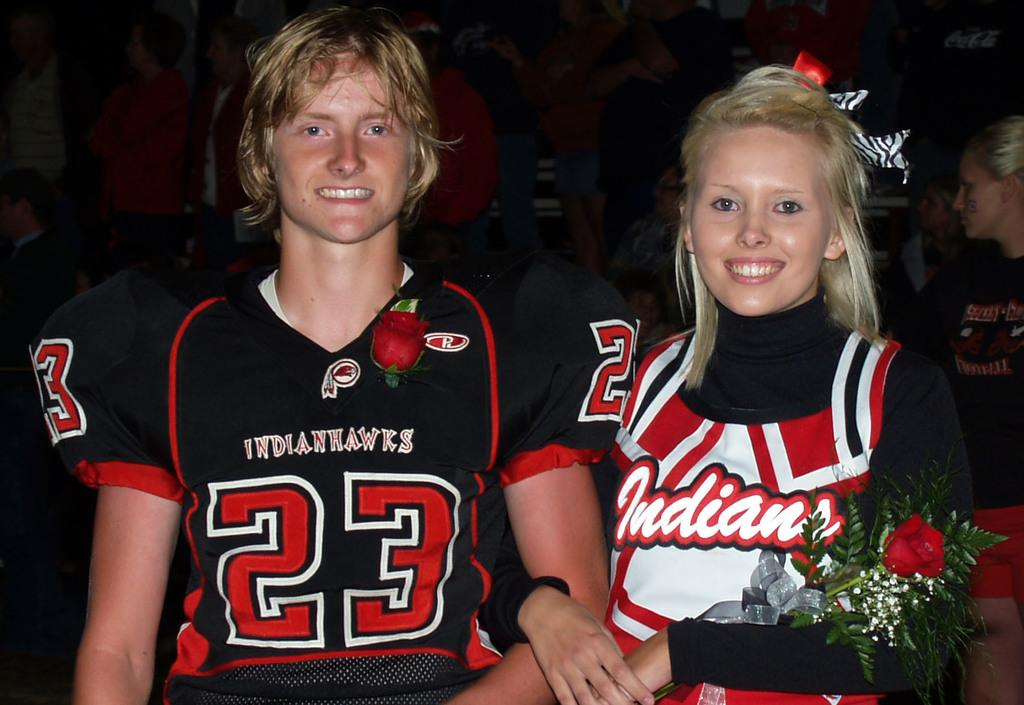Provide a one-sentence caption for the provided image. An Indians cheerleader holds a rose next to number 23 of the football team. 